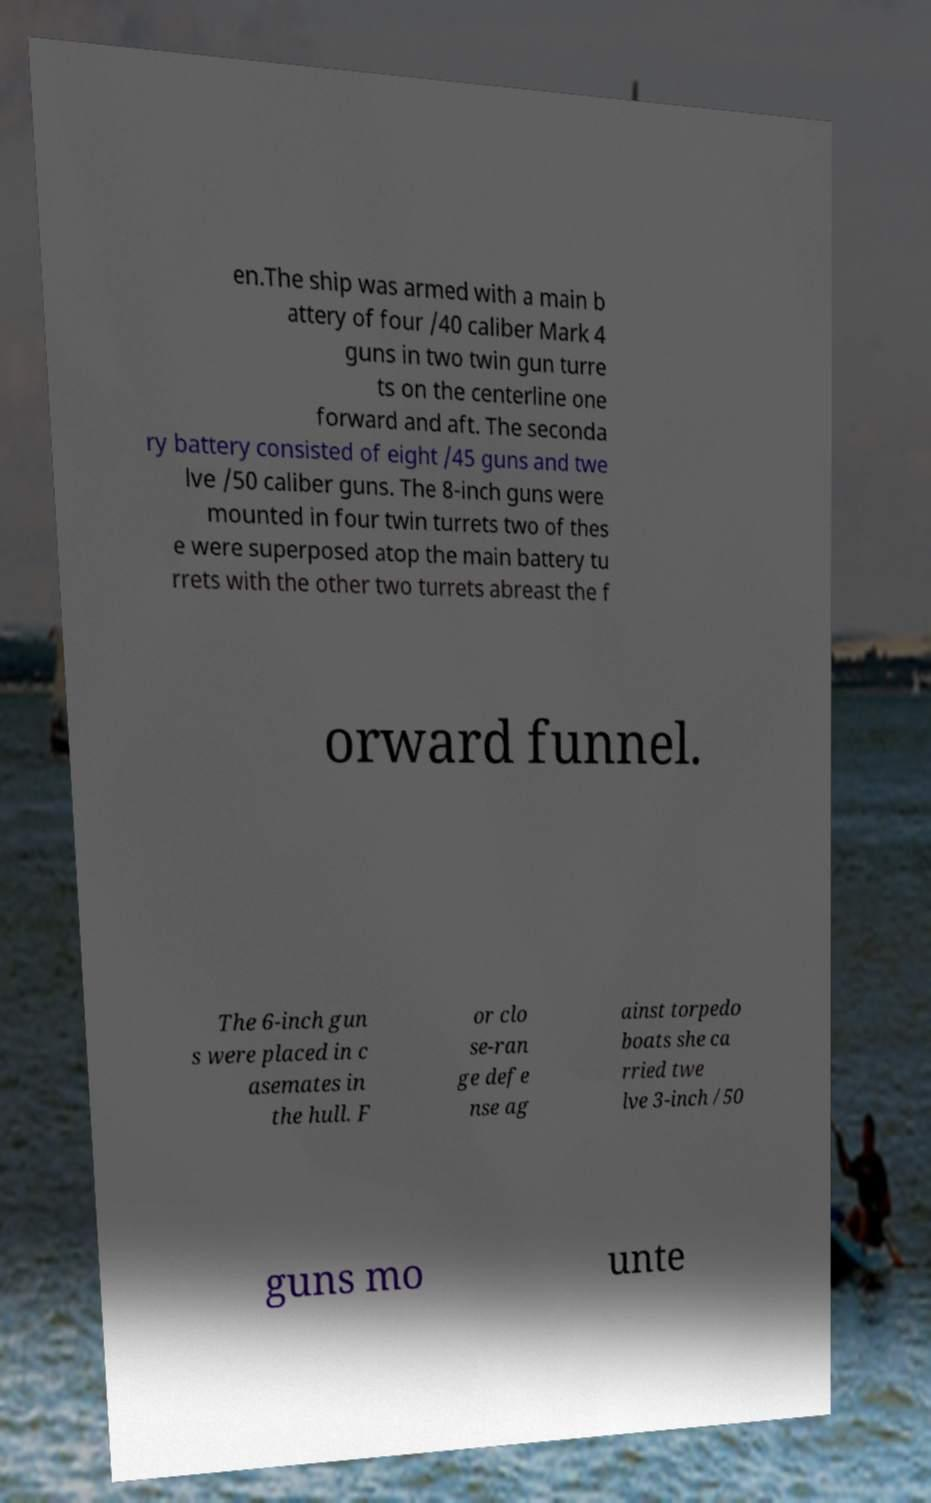Can you accurately transcribe the text from the provided image for me? en.The ship was armed with a main b attery of four /40 caliber Mark 4 guns in two twin gun turre ts on the centerline one forward and aft. The seconda ry battery consisted of eight /45 guns and twe lve /50 caliber guns. The 8-inch guns were mounted in four twin turrets two of thes e were superposed atop the main battery tu rrets with the other two turrets abreast the f orward funnel. The 6-inch gun s were placed in c asemates in the hull. F or clo se-ran ge defe nse ag ainst torpedo boats she ca rried twe lve 3-inch /50 guns mo unte 